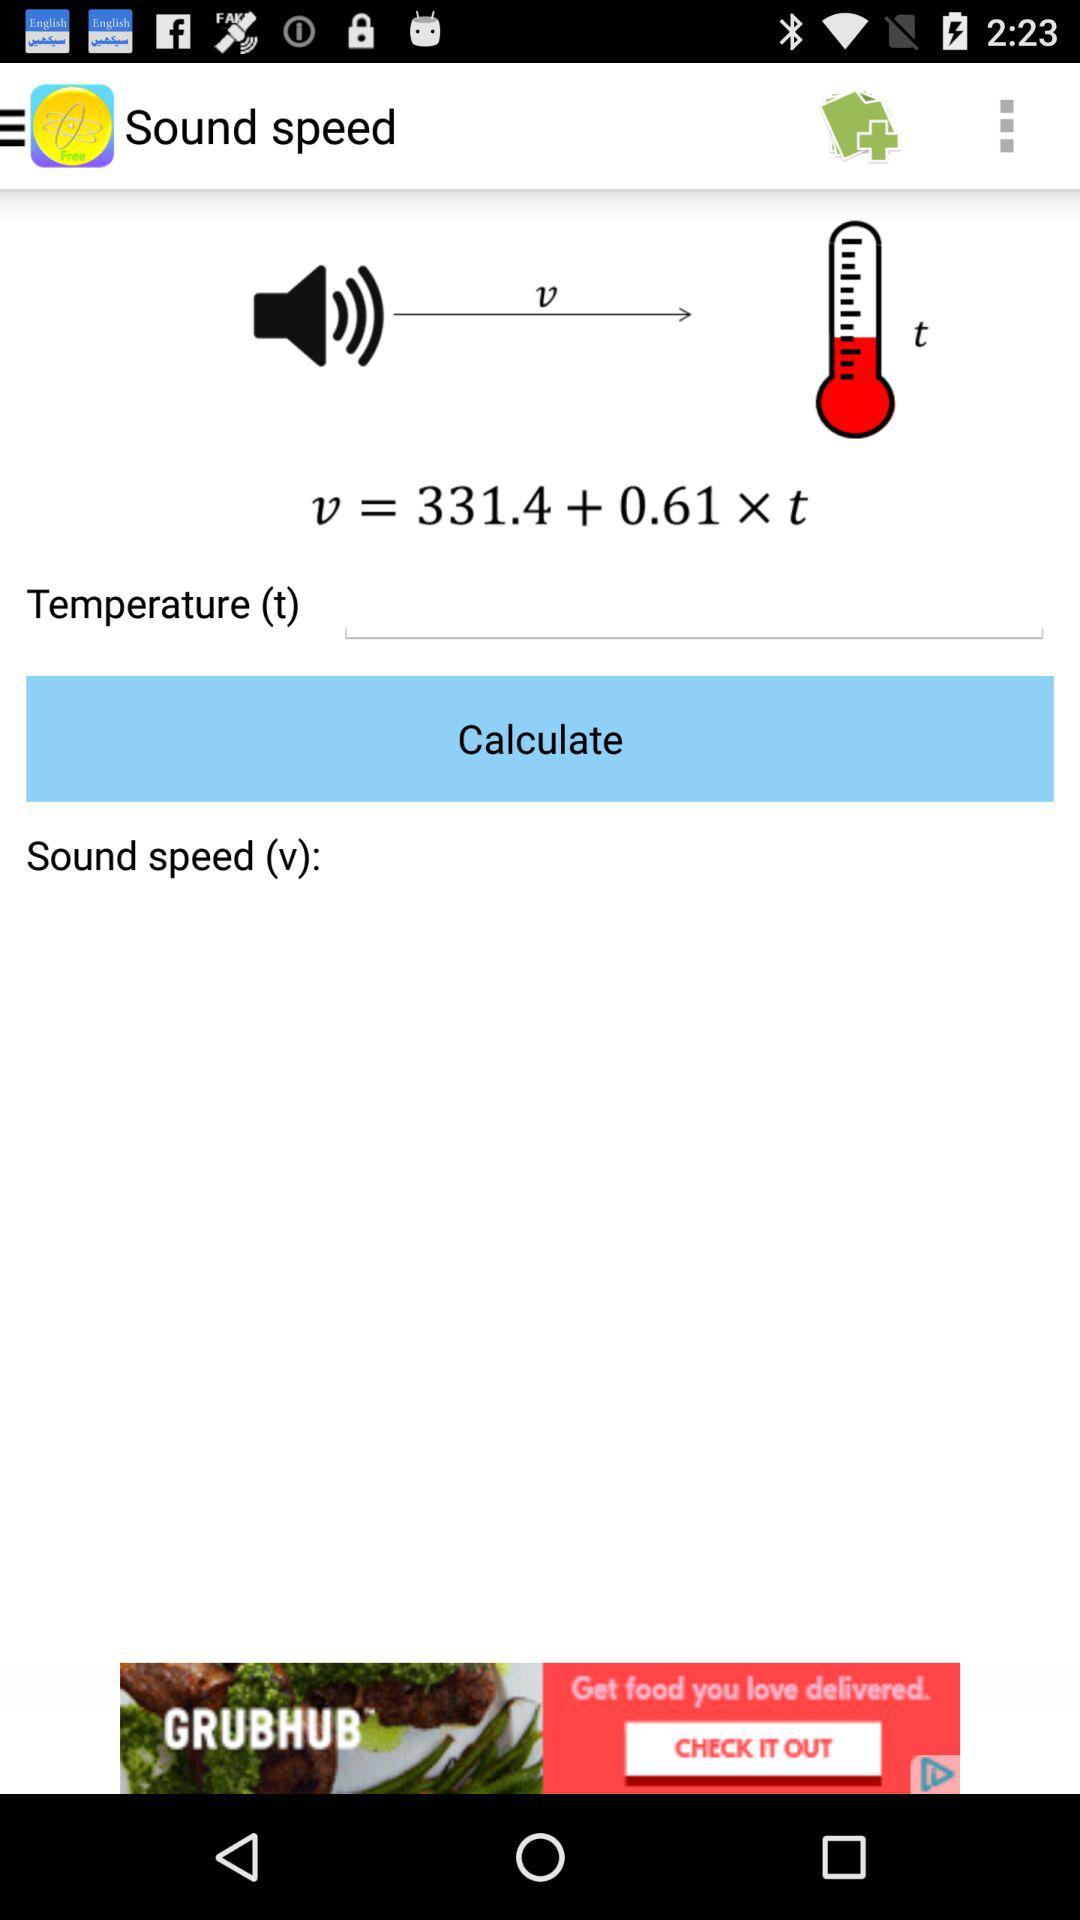What is the application name? The application name is "Physics Formulas Free". 